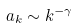<formula> <loc_0><loc_0><loc_500><loc_500>a _ { k } \sim k ^ { - \gamma }</formula> 